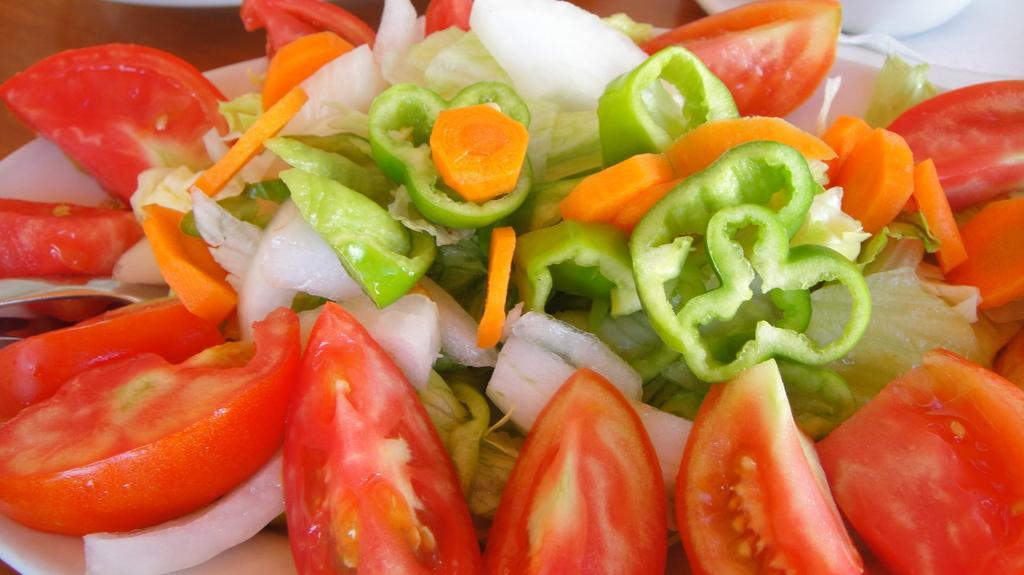Could you give a brief overview of what you see in this image? In this picture there is salad in the center of the image, which contains tomatoes, capsicum, and other vegetables. 